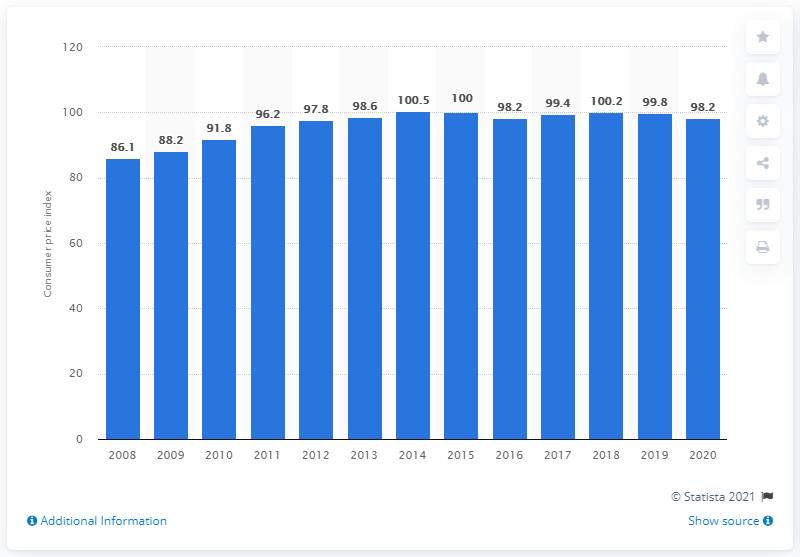List a handful of essential elements in this visual. In 2020, the price index value of household appliances was 98.2. 